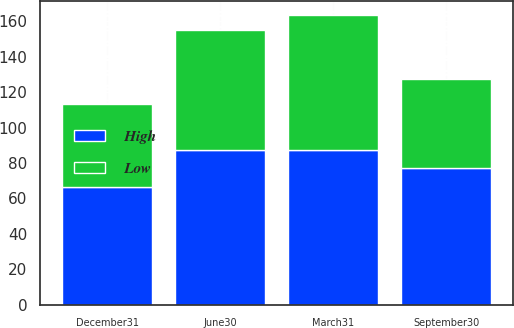<chart> <loc_0><loc_0><loc_500><loc_500><stacked_bar_chart><ecel><fcel>March31<fcel>June30<fcel>September30<fcel>December31<nl><fcel>High<fcel>87.4<fcel>87.19<fcel>77.12<fcel>66.49<nl><fcel>Low<fcel>76<fcel>67.65<fcel>50.42<fcel>46.66<nl></chart> 